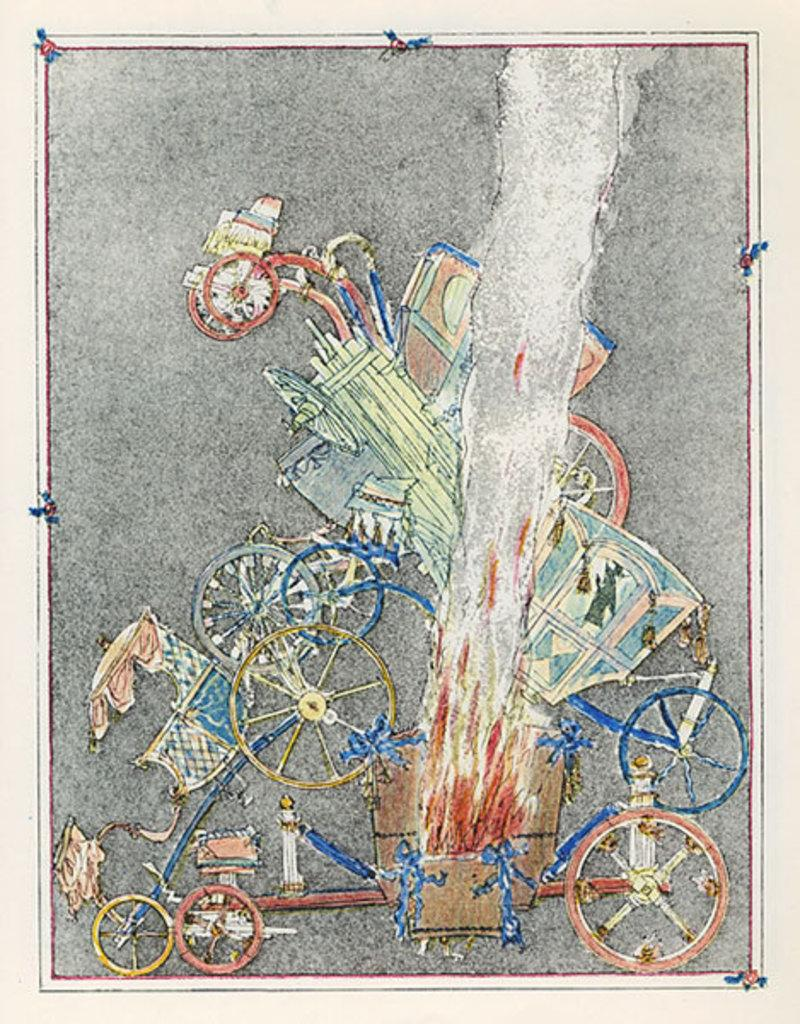What type of objects are present in the image? There are carts in the image. What feature do the carts have? The carts have wheels. Can you describe the color scheme of the image? The image uses blue, yellow, brown, and ash colors. How many boats can be seen in the image? There are no boats present in the image; it features carts with wheels. Is there a pig visible in the image? There is no pig present in the image. 